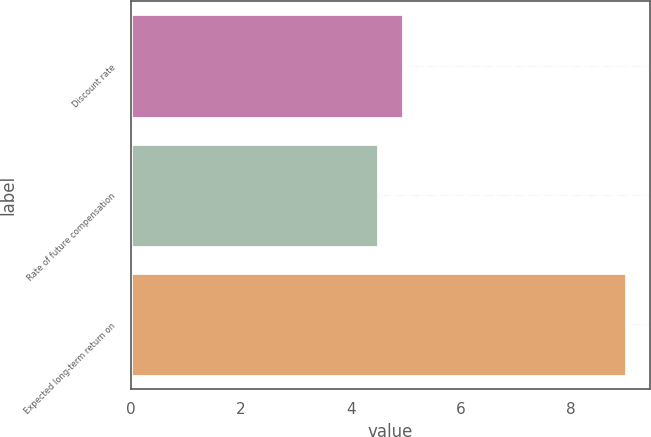<chart> <loc_0><loc_0><loc_500><loc_500><bar_chart><fcel>Discount rate<fcel>Rate of future compensation<fcel>Expected long-term return on<nl><fcel>4.95<fcel>4.5<fcel>9<nl></chart> 